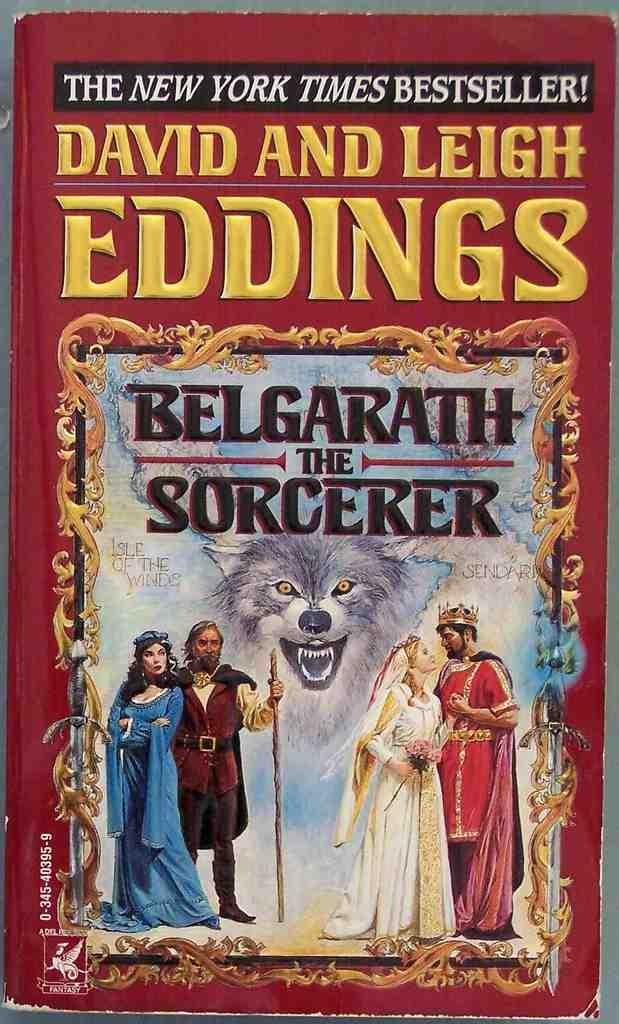<image>
Share a concise interpretation of the image provided. A red book with the title Belgarath the Sorcerer. 